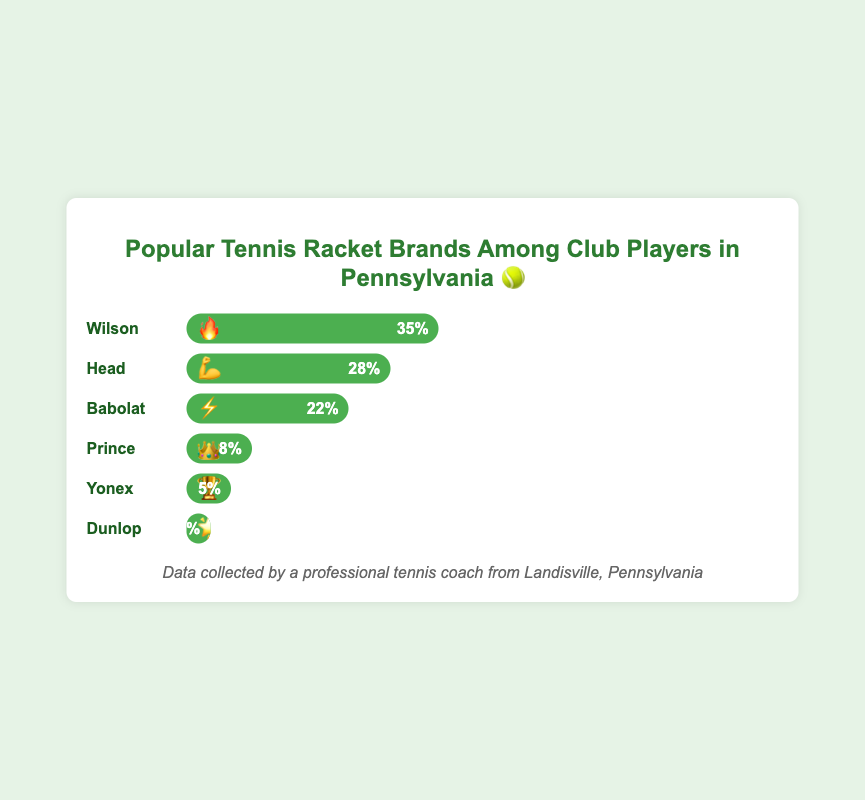Which brand has the highest popularity among club players in Pennsylvania? The figure shows several racket brands with Wilson having the highest bar length at 35%, indicating it has the highest popularity.
Answer: Wilson How much more popular is Wilson compared to Babolat? Wilson has a popularity of 35% while Babolat has a popularity of 22%. The difference is 35% - 22% = 13%.
Answer: 13% Which two brands combined make up more than half of the club players' preferences? Wilson has 35% and Head has 28%. Adding these together gives 35% + 28% = 63%, which is more than half.
Answer: Wilson and Head What percentage of club players prefer Yonex? The bar for Yonex reaches 5%, as indicated by the percentage on the bar.
Answer: 5% Sum up the percentage of popularity for Prince, Yonex, and Dunlop. Prince has 8%, Yonex has 5%, and Dunlop has 2%. Adding these together gives 8% + 5% + 2% = 15%.
Answer: 15% Which brand has the trophy emoji beside it? 🏆 By examining the emojis next to each brand, Yonex has the trophy emoji.
Answer: Yonex Compare the popularity of Head and Babolat. Which one is more popular? Head has a popularity of 28% while Babolat has 22%. Thus, Head is more popular.
Answer: Head Is the sum of the popularities of Babolat and Prince greater than Wilson? Adding Babolat (22%) and Prince (8%) gives 22% + 8% = 30%, which is less than Wilson's 35%.
Answer: No What is the combined popularity percentage of the three least popular brands? The three least popular brands are Prince (8%), Yonex (5%), and Dunlop (2%). Summing these gives 8% + 5% + 2% = 15%.
Answer: 15% What is the fire emoji associated with? 🔥 The fire emoji is next to the brand Wilson, indicating a high level of popularity.
Answer: Wilson 